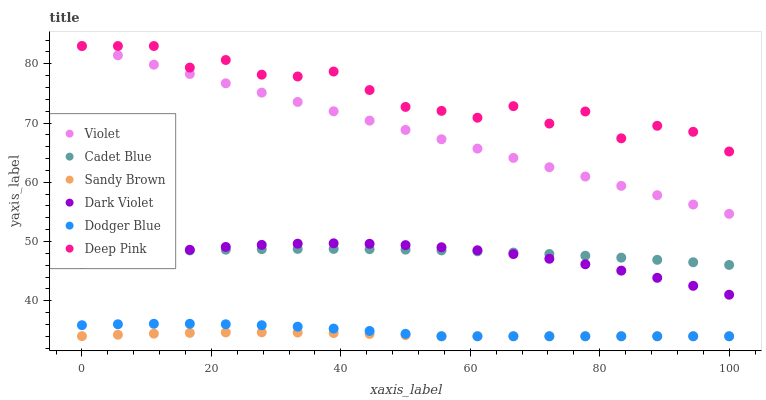Does Sandy Brown have the minimum area under the curve?
Answer yes or no. Yes. Does Deep Pink have the maximum area under the curve?
Answer yes or no. Yes. Does Dark Violet have the minimum area under the curve?
Answer yes or no. No. Does Dark Violet have the maximum area under the curve?
Answer yes or no. No. Is Violet the smoothest?
Answer yes or no. Yes. Is Deep Pink the roughest?
Answer yes or no. Yes. Is Dark Violet the smoothest?
Answer yes or no. No. Is Dark Violet the roughest?
Answer yes or no. No. Does Dodger Blue have the lowest value?
Answer yes or no. Yes. Does Dark Violet have the lowest value?
Answer yes or no. No. Does Violet have the highest value?
Answer yes or no. Yes. Does Dark Violet have the highest value?
Answer yes or no. No. Is Dodger Blue less than Dark Violet?
Answer yes or no. Yes. Is Dark Violet greater than Dodger Blue?
Answer yes or no. Yes. Does Dodger Blue intersect Sandy Brown?
Answer yes or no. Yes. Is Dodger Blue less than Sandy Brown?
Answer yes or no. No. Is Dodger Blue greater than Sandy Brown?
Answer yes or no. No. Does Dodger Blue intersect Dark Violet?
Answer yes or no. No. 